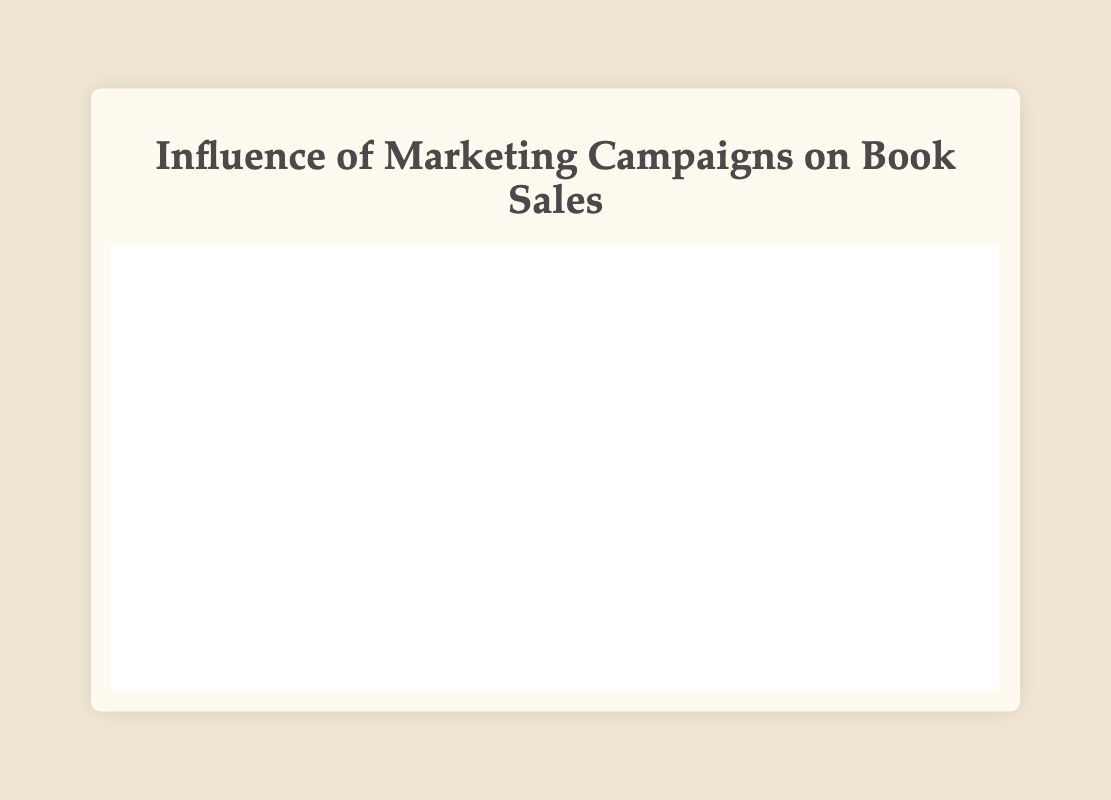What is the pattern of sales growth for the “Social Media Influencers” campaign? The “Social Media Influencers” campaign started with sales of 100 in the first week and peaked at 600 in the fourth week. Following that, sales declined to 500 and then 400.
Answer: An initial increase followed by a peak and then a decline Which campaign had the highest peak sales, and what was the value? By comparing the peak sales values, the “Radio and TV Ads” campaign had the highest peak at 800.
Answer: Radio and TV Ads with 800 sales How did sales trend in the final week of the “Email Marketing” campaign compare with the first week of the “Book Signing Events” campaign? Sales in the final week of the “Email Marketing” campaign were 300, while in the first week of the “Book Signing Events” campaign, sales were 200.
Answer: Email Marketing had higher sales at 300 Which campaign showed a consistent increase in sales and what were the sales in the last week of that trend? “Book Signing Events” consistently increased from 200 to a peak of 700. The sales in the last week of this consistent trend were 700.
Answer: Book Signing Events, 700 sales If we sum the peak sales of “Social Media Influencers” and “Online Bookstore Features,” what is the total? The peak sales for “Social Media Influencers” are 600 and for “Online Bookstore Features” are 650. Summing these gives 600 + 650 = 1250.
Answer: 1250 Which campaign started with the highest sales, and what was the value? The “Radio and TV Ads” campaign started with the highest sales value of 300.
Answer: Radio and TV Ads, 300 sales How does the sales trend of the “Online Bookstore Features” compare to the “Radio and TV Ads” campaign in their final reported week? The “Online Bookstore Features” had sales of 500 in the final reported week, while the “Radio and TV Ads” had sales of 650.
Answer: Radio and TV Ads had higher final week sales at 650 What visual attribute differentiates the “Social Media Influencers” campaign from the others? Visually, the “Social Media Influencers” sales curve is identified by the starting point of the lowest sales and a rapid increase to a peak before a decline.
Answer: Rapid initial increase and then a decline How much higher were the peak sales of “Radio and TV Ads” compared to “Email Marketing”? The peak sales for “Radio and TV Ads” were 800, and for “Email Marketing,” they were 450. The difference is 800 - 450 = 350.
Answer: 350 